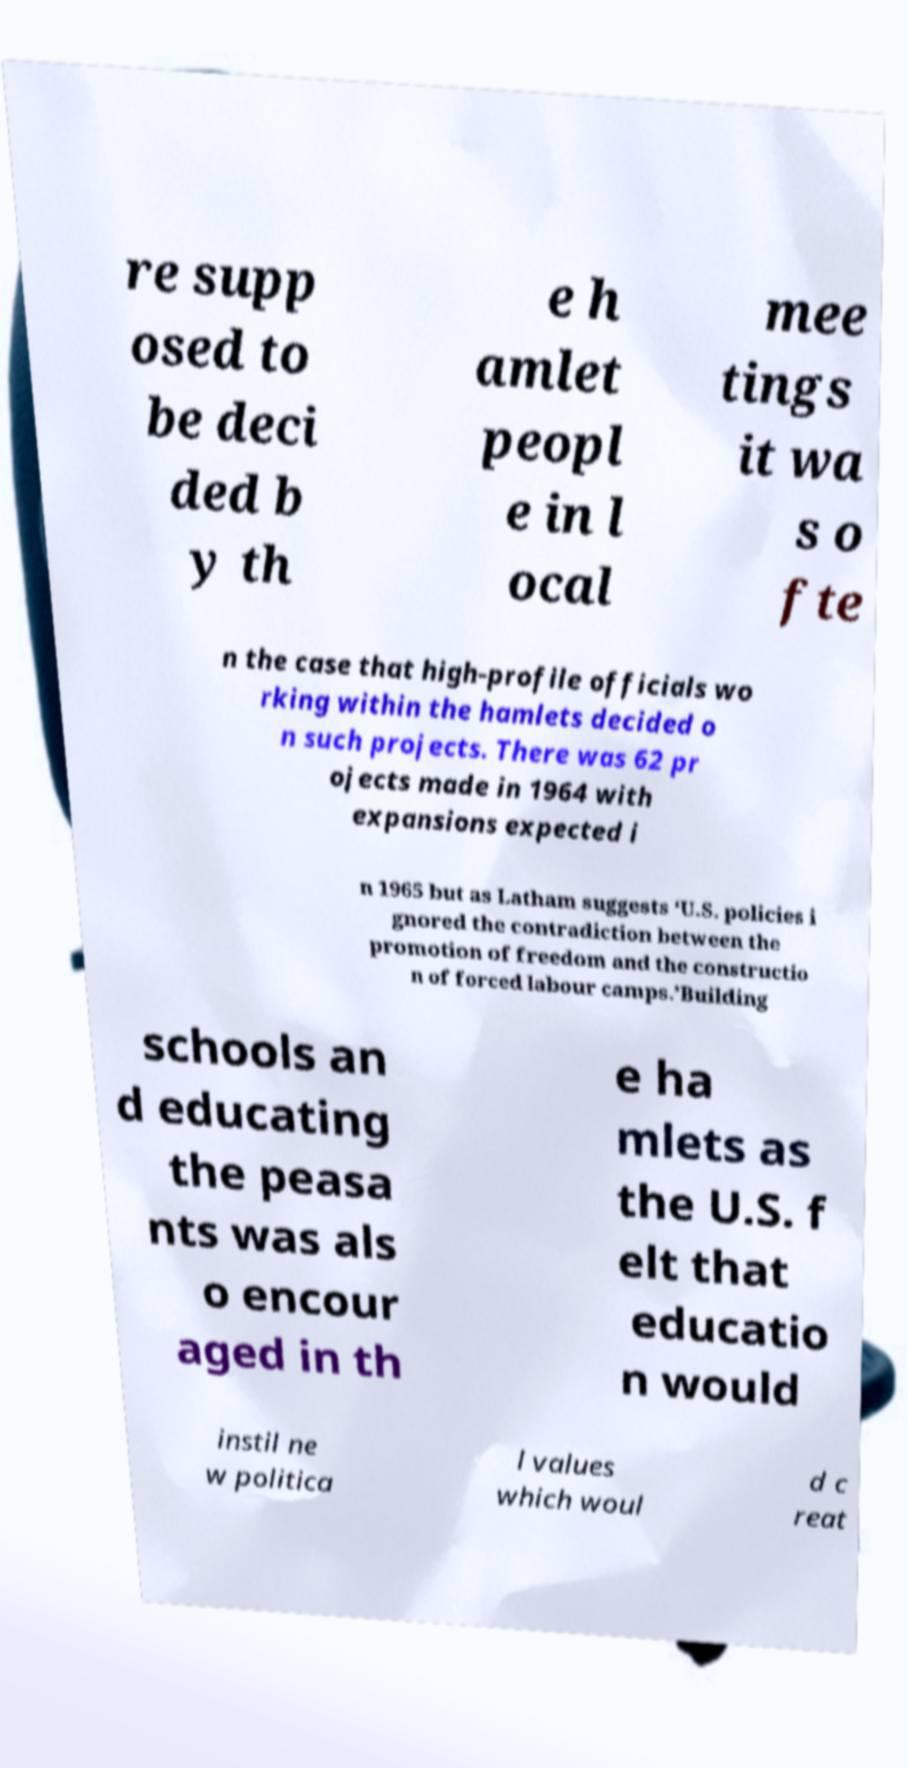Could you extract and type out the text from this image? re supp osed to be deci ded b y th e h amlet peopl e in l ocal mee tings it wa s o fte n the case that high-profile officials wo rking within the hamlets decided o n such projects. There was 62 pr ojects made in 1964 with expansions expected i n 1965 but as Latham suggests ‘U.S. policies i gnored the contradiction between the promotion of freedom and the constructio n of forced labour camps.’Building schools an d educating the peasa nts was als o encour aged in th e ha mlets as the U.S. f elt that educatio n would instil ne w politica l values which woul d c reat 